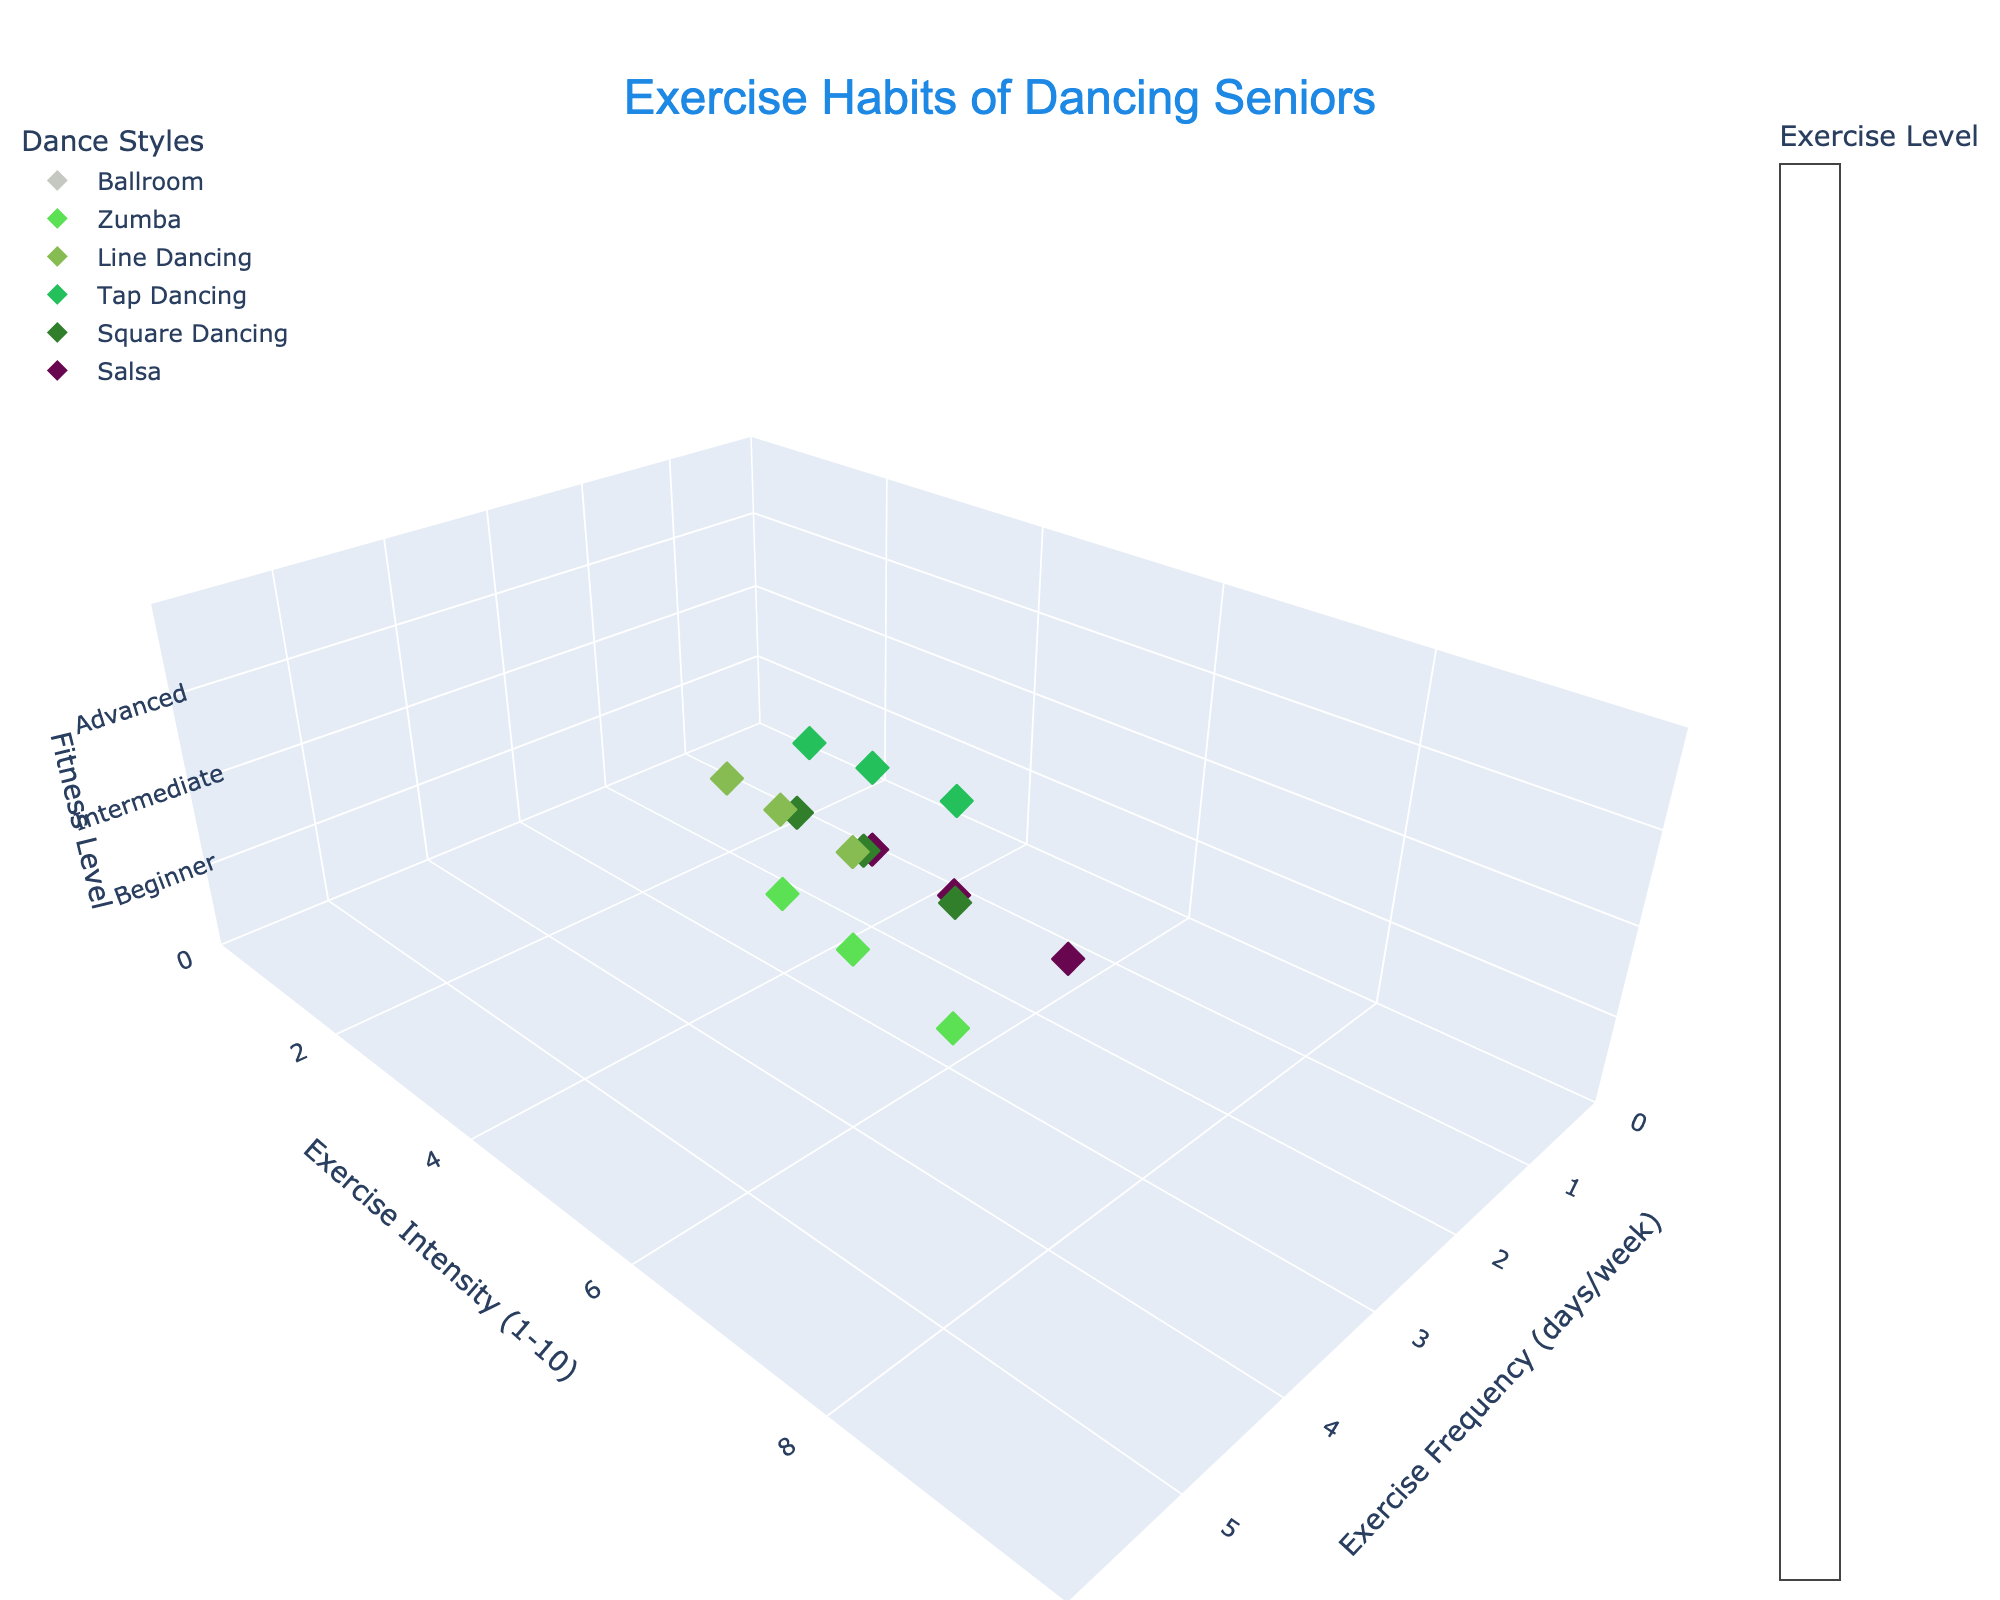What is the title of the figure? The title is displayed at the top of the figure, typically in larger font size to make it stand out. It serves as a summary of what the figure is about. In this case, it reads: "Exercise Habits of Dancing Seniors".
Answer: Exercise Habits of Dancing Seniors How many fitness levels are shown on the figure? The z-axis of the figure represents the fitness levels, which are categorized into three levels: Beginner, Intermediate, and Advanced. These levels are indicated and should be counted directly from the axis labels.
Answer: 3 Which dance style has the highest intensity at the beginner fitness level? To determine this, we focus on the dance styles that are marked as Beginner and then compare their exercise intensity values (on the y-axis). Among the beginner levels, Salsa has the highest intensity value of 4.
Answer: Salsa What is the exercise frequency for advanced Zumba dancers? To answer this, locate the points for Zumba that are marked as Advanced on the fitness level (z-axis). All these points give an exercise frequency value from the x-axis. For Zumba at the Advanced level, the exercise frequency is 5 days/week.
Answer: 5 days/week Which dance style has the lowest intensity for intermediate dancers? Check the intermediate level on the z-axis, and identify each dance style's intensity on the y-axis. Compare these values to find the lowest. Line Dancing has an intensity value of 4, which is the lowest among the intermediate levels.
Answer: Line Dancing What is the total exercise frequency for all beginner dancers? Sum up the exercise frequency values (x-axis) for all points marked as Beginner on the z-axis, i.e., Ballroom (2), Zumba (3), Line Dancing (2), Tap Dancing (1), Square Dancing (2), Salsa (2). Total = 2 + 3 + 2 + 1 + 2 + 2 = 12 days/week.
Answer: 12 days/week Between ballroom and salsa, which has higher exercise intensity for advanced-level dancers? On the z-axis, find the points marked as Advanced for both dance styles, then compare their exercise intensity values (y-axis). Ballroom's intensity is 7, while Salsa's intensity is 8, showing Salsa has a higher intensity.
Answer: Salsa What is the average exercise intensity for intermediate-level dancers across all dance styles? Sum the intensity values for all intermediate dancers and divide by the number of such dancers. Intensities: Ballroom (5), Zumba (6), Line Dancing (4), Tap Dancing (4), Square Dancing (5), Salsa (6). (5+6+4+4+5+6) / 6 = 30/6 = 5.
Answer: 5 What dance styles have the same exercise frequency across all their fitness levels? Check each dance style to see if they have the same exercise frequency listed on the x-axis for Beginners, Intermediate, and Advanced. None of the styles maintain a constant exercise frequency across all levels.
Answer: None 